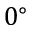Convert formula to latex. <formula><loc_0><loc_0><loc_500><loc_500>0 ^ { \circ }</formula> 